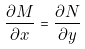<formula> <loc_0><loc_0><loc_500><loc_500>\frac { \partial M } { \partial x } = \frac { \partial N } { \partial y }</formula> 